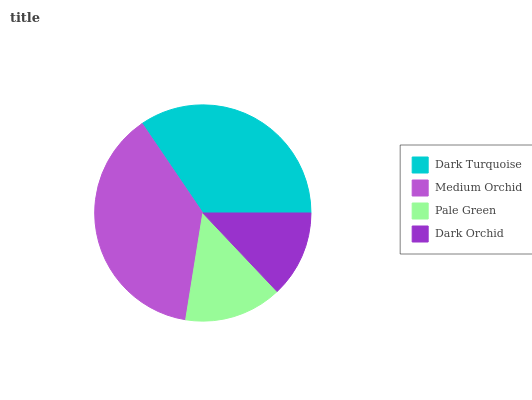Is Dark Orchid the minimum?
Answer yes or no. Yes. Is Medium Orchid the maximum?
Answer yes or no. Yes. Is Pale Green the minimum?
Answer yes or no. No. Is Pale Green the maximum?
Answer yes or no. No. Is Medium Orchid greater than Pale Green?
Answer yes or no. Yes. Is Pale Green less than Medium Orchid?
Answer yes or no. Yes. Is Pale Green greater than Medium Orchid?
Answer yes or no. No. Is Medium Orchid less than Pale Green?
Answer yes or no. No. Is Dark Turquoise the high median?
Answer yes or no. Yes. Is Pale Green the low median?
Answer yes or no. Yes. Is Dark Orchid the high median?
Answer yes or no. No. Is Dark Turquoise the low median?
Answer yes or no. No. 